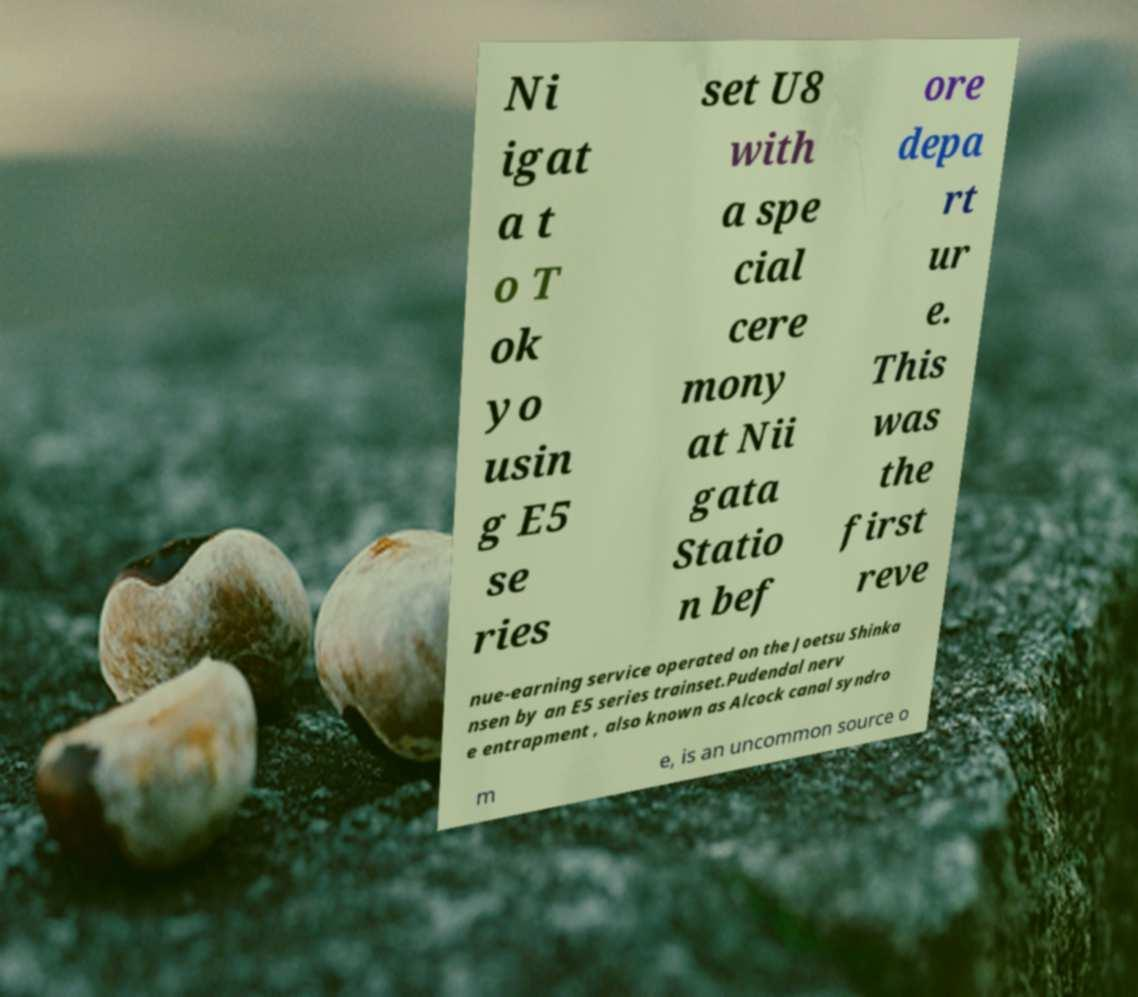Could you assist in decoding the text presented in this image and type it out clearly? Ni igat a t o T ok yo usin g E5 se ries set U8 with a spe cial cere mony at Nii gata Statio n bef ore depa rt ur e. This was the first reve nue-earning service operated on the Joetsu Shinka nsen by an E5 series trainset.Pudendal nerv e entrapment , also known as Alcock canal syndro m e, is an uncommon source o 